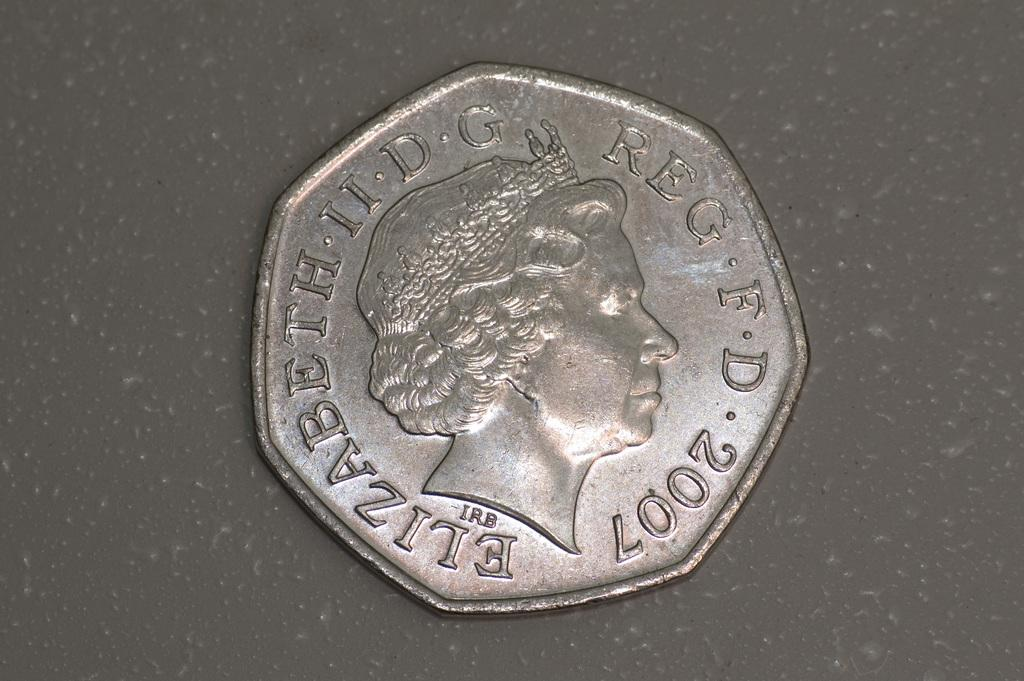Provide a one-sentence caption for the provided image. A metallic coin from 2007 has Elizabeth II engraved on it. 